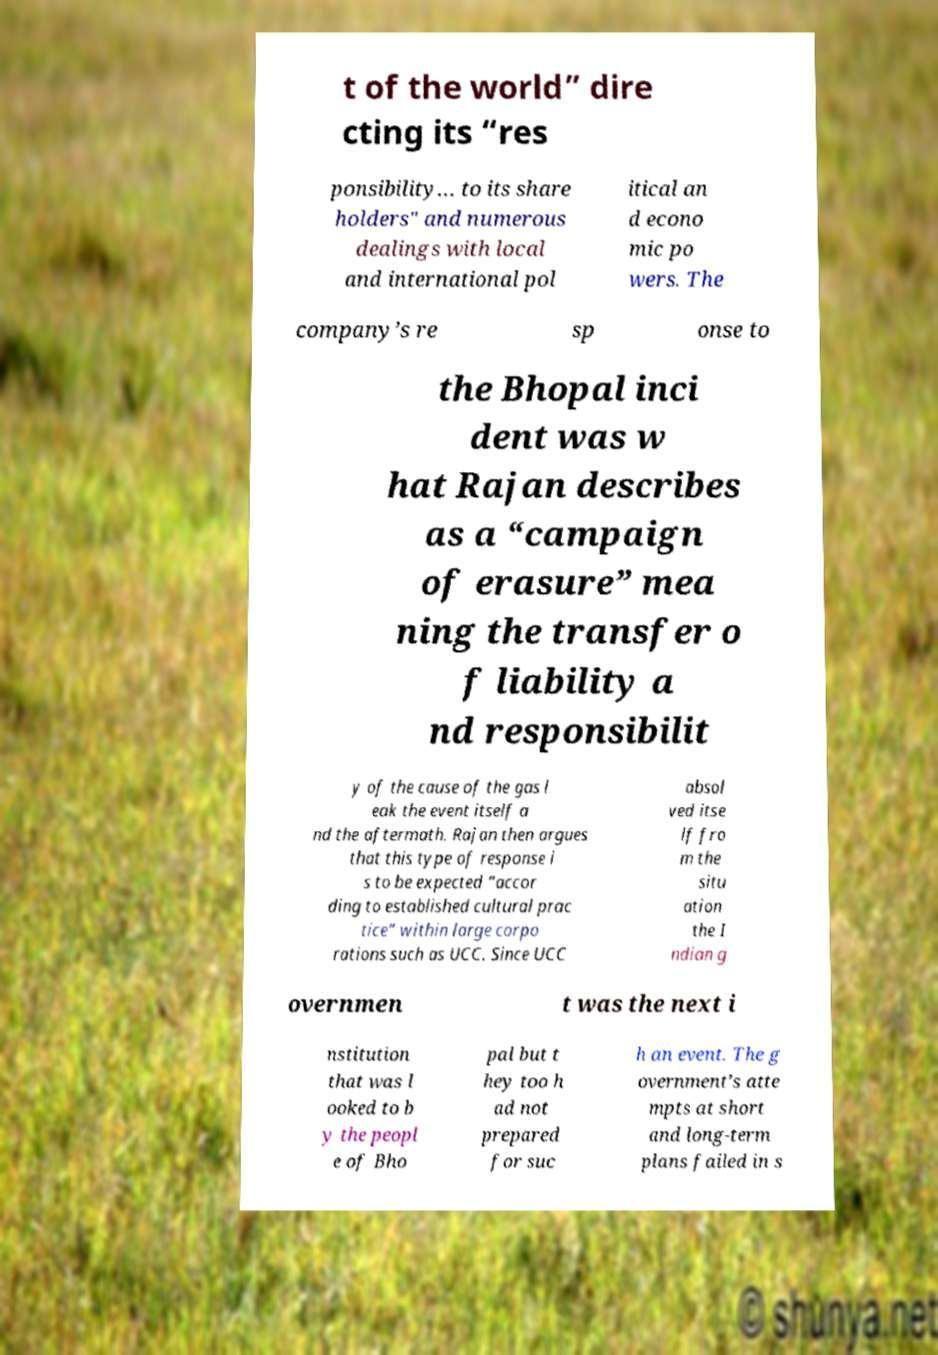I need the written content from this picture converted into text. Can you do that? t of the world” dire cting its “res ponsibility… to its share holders" and numerous dealings with local and international pol itical an d econo mic po wers. The company’s re sp onse to the Bhopal inci dent was w hat Rajan describes as a “campaign of erasure” mea ning the transfer o f liability a nd responsibilit y of the cause of the gas l eak the event itself a nd the aftermath. Rajan then argues that this type of response i s to be expected “accor ding to established cultural prac tice” within large corpo rations such as UCC. Since UCC absol ved itse lf fro m the situ ation the I ndian g overnmen t was the next i nstitution that was l ooked to b y the peopl e of Bho pal but t hey too h ad not prepared for suc h an event. The g overnment’s atte mpts at short and long-term plans failed in s 